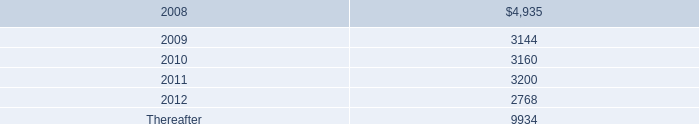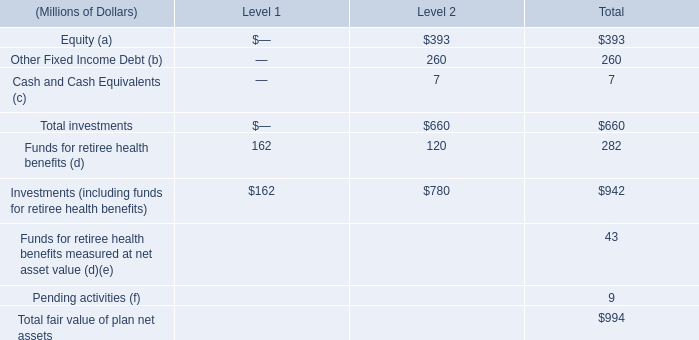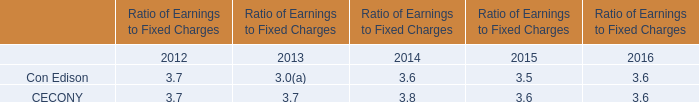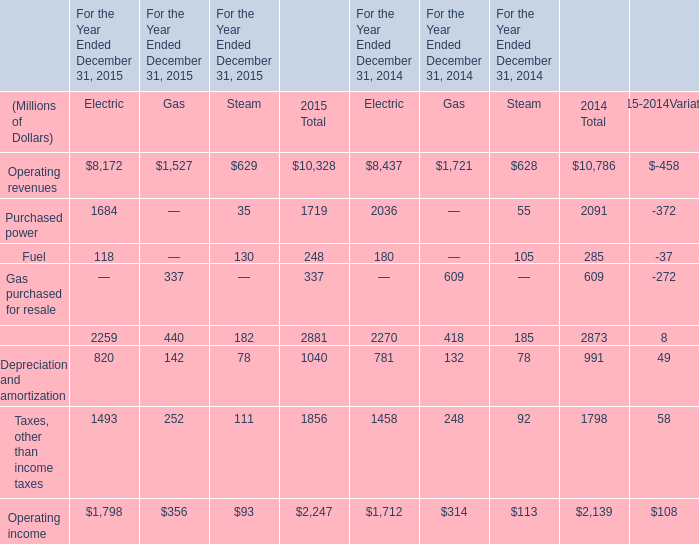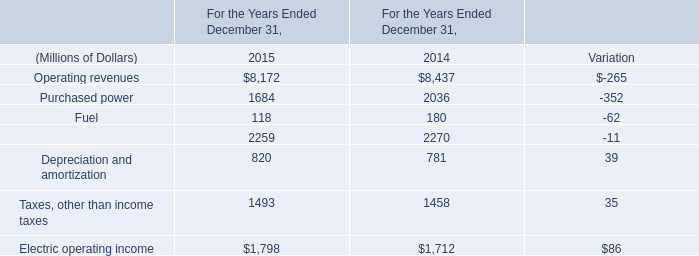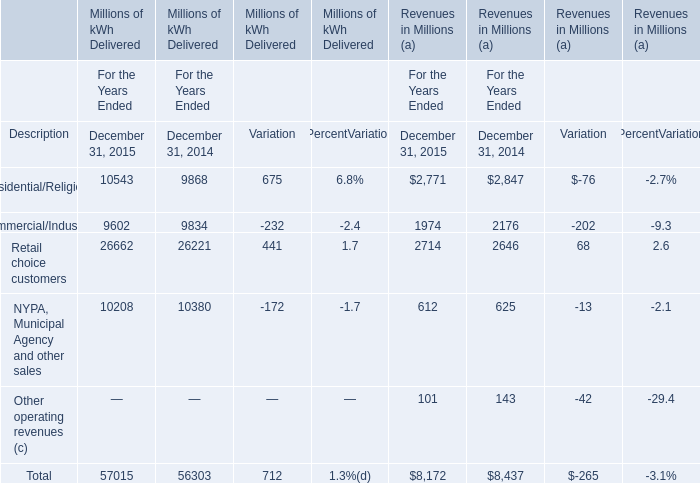What's the average of Operating revenues and Purchased power in 2015? (in million) 
Computations: ((8172 + 1684) / 2)
Answer: 4928.0. 